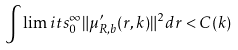Convert formula to latex. <formula><loc_0><loc_0><loc_500><loc_500>\int \lim i t s _ { 0 } ^ { \infty } \| \mu ^ { \prime } _ { R , b } ( r , k ) \| ^ { 2 } d r < C ( k )</formula> 